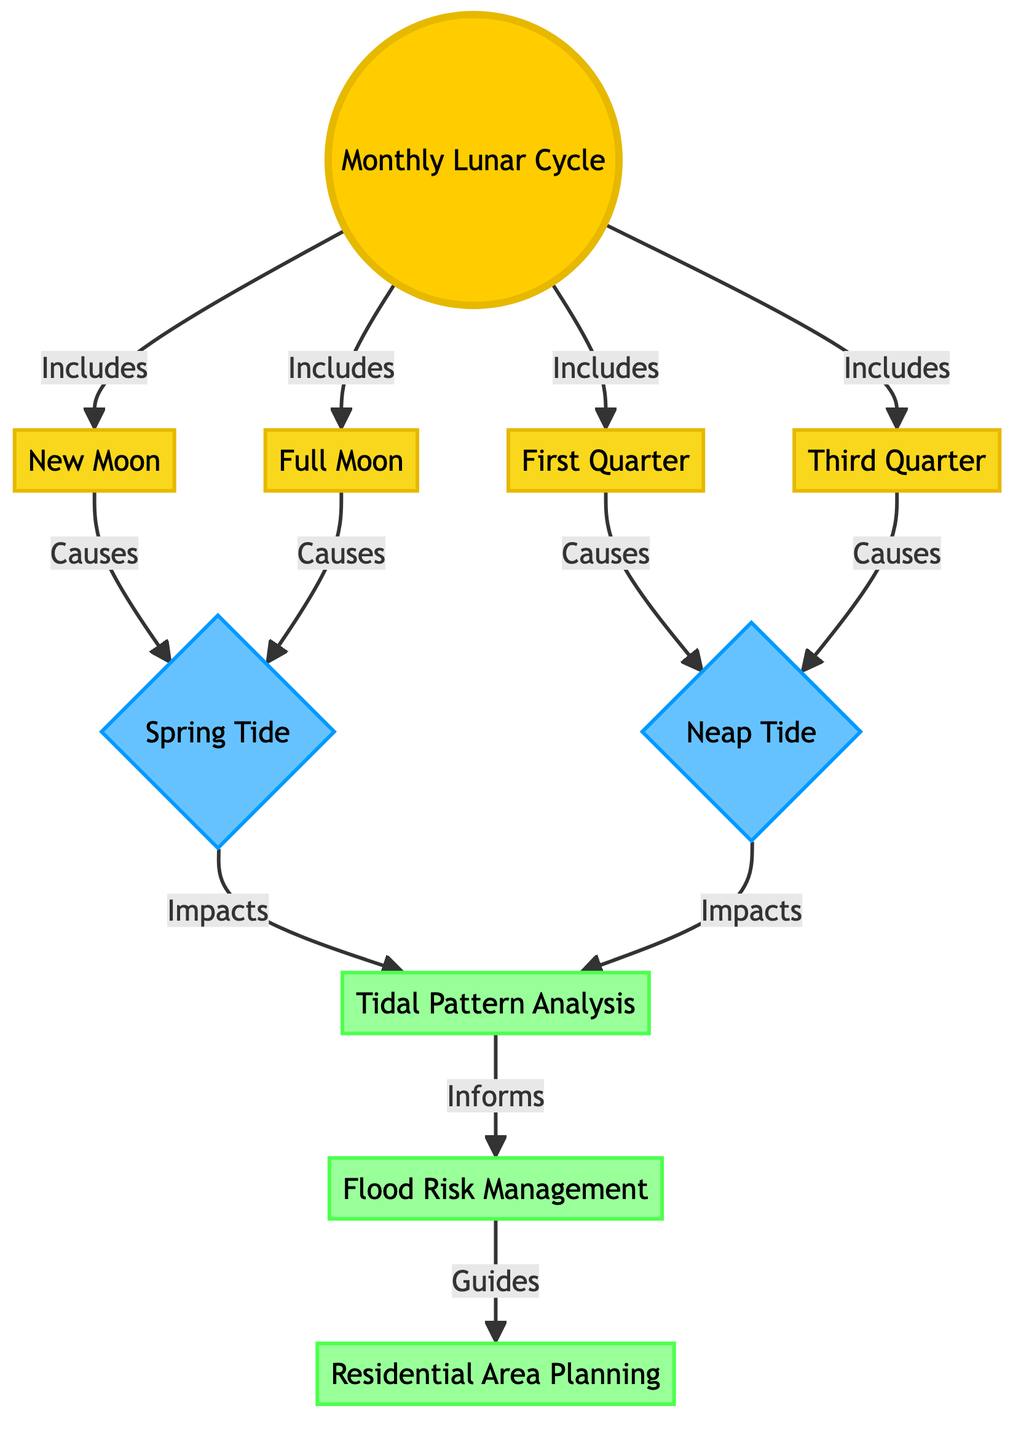What are the phases included in the Monthly Lunar Cycle? The diagram indicates that the Monthly Lunar Cycle includes New Moon, Full Moon, First Quarter, and Third Quarter. This can be seen directly as each phase is connected to the Monthly Lunar Cycle node with an "Includes" label.
Answer: New Moon, Full Moon, First Quarter, Third Quarter How many tidal types are connected to the lunar phases? The diagram shows that each of the lunar phases is associated with either Spring Tide or Neap Tide. There are two tidal types identified: Spring Tide and Neap Tide. Therefore, counting both gives us a total of two.
Answer: 2 Which lunar phases cause Spring Tide? According to the diagram, both New Moon and Full Moon cause Spring Tide, as indicated by the arrows labeled "Causes" leading from these lunar phases to the tidal type.
Answer: New Moon, Full Moon What informs Flood Risk Management? The diagram illustrates that Tidal Pattern Analysis informs Flood Risk Management, as represented by the arrow labeled "Informs" leading from Tidal Pattern Analysis to Flood Risk Management.
Answer: Tidal Pattern Analysis How does Flood Risk Management affect Residential Area Planning? The diagram directly shows that Flood Risk Management guides Residential Area Planning, which is represented by an arrow labeled "Guides" from Flood Risk Management to Residential Area Planning.
Answer: Guides How many connections lead from the Monthly Lunar Cycle node? In the diagram, the Monthly Lunar Cycle node connects to four other nodes (New Moon, Full Moon, First Quarter, Third Quarter), indicating the various lunar phases it includes implying there are four connections.
Answer: 4 What type of tide is generated by the First Quarter lunar phase? The diagram specifies that the First Quarter causes Neap Tide, which is indicated by the arrow labeled "Causes" leading from First Quarter to the Neap Tide node.
Answer: Neap Tide Which tidal type impacts Tidal Pattern Analysis? The diagram mentions that both Spring Tide and Neap Tide impact Tidal Pattern Analysis, as indicated by arrows pointing towards it from both tidal types.
Answer: Spring Tide, Neap Tide What is the main focus of the flow from Tidal Pattern Analysis? The flow from Tidal Pattern Analysis leads towards Flood Risk Management, indicating that its main focus or impact is on informing flood risk management decisions.
Answer: Flood Risk Management 